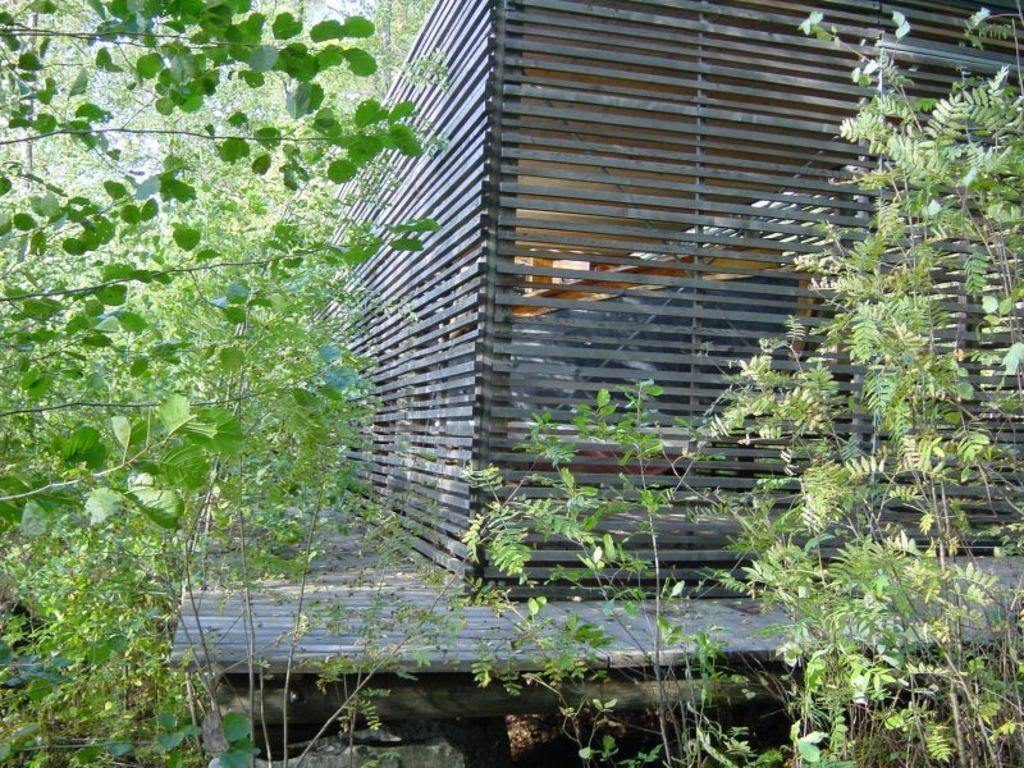Please provide a concise description of this image. In this picture we see a wooden house and few trees and plants. 